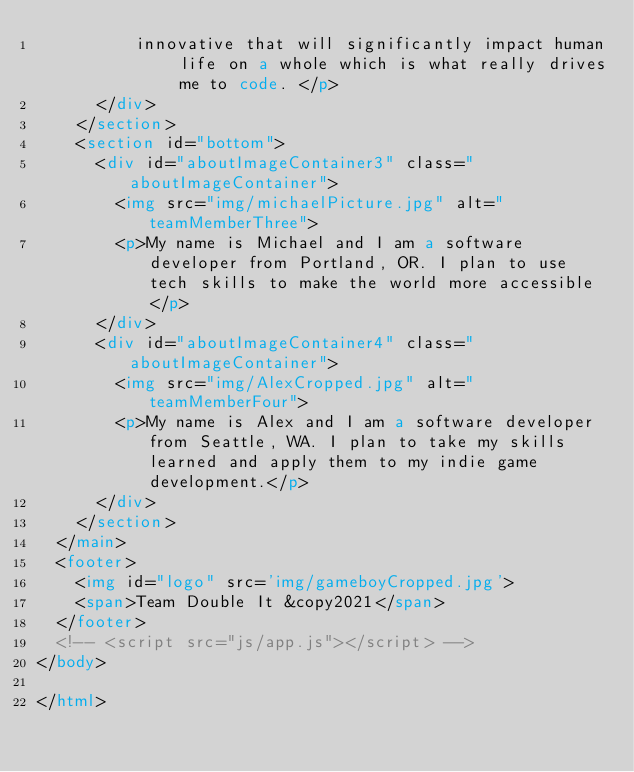<code> <loc_0><loc_0><loc_500><loc_500><_HTML_>          innovative that will significantly impact human life on a whole which is what really drives me to code. </p>
      </div>
    </section>
    <section id="bottom">
      <div id="aboutImageContainer3" class="aboutImageContainer">
        <img src="img/michaelPicture.jpg" alt="teamMemberThree">
        <p>My name is Michael and I am a software developer from Portland, OR. I plan to use tech skills to make the world more accessible</p>
      </div>
      <div id="aboutImageContainer4" class="aboutImageContainer">
        <img src="img/AlexCropped.jpg" alt="teamMemberFour">
        <p>My name is Alex and I am a software developer from Seattle, WA. I plan to take my skills learned and apply them to my indie game development.</p>
      </div>
    </section>
  </main>
  <footer>
    <img id="logo" src='img/gameboyCropped.jpg'>
    <span>Team Double It &copy2021</span>
  </footer>
  <!-- <script src="js/app.js"></script> -->
</body>

</html></code> 